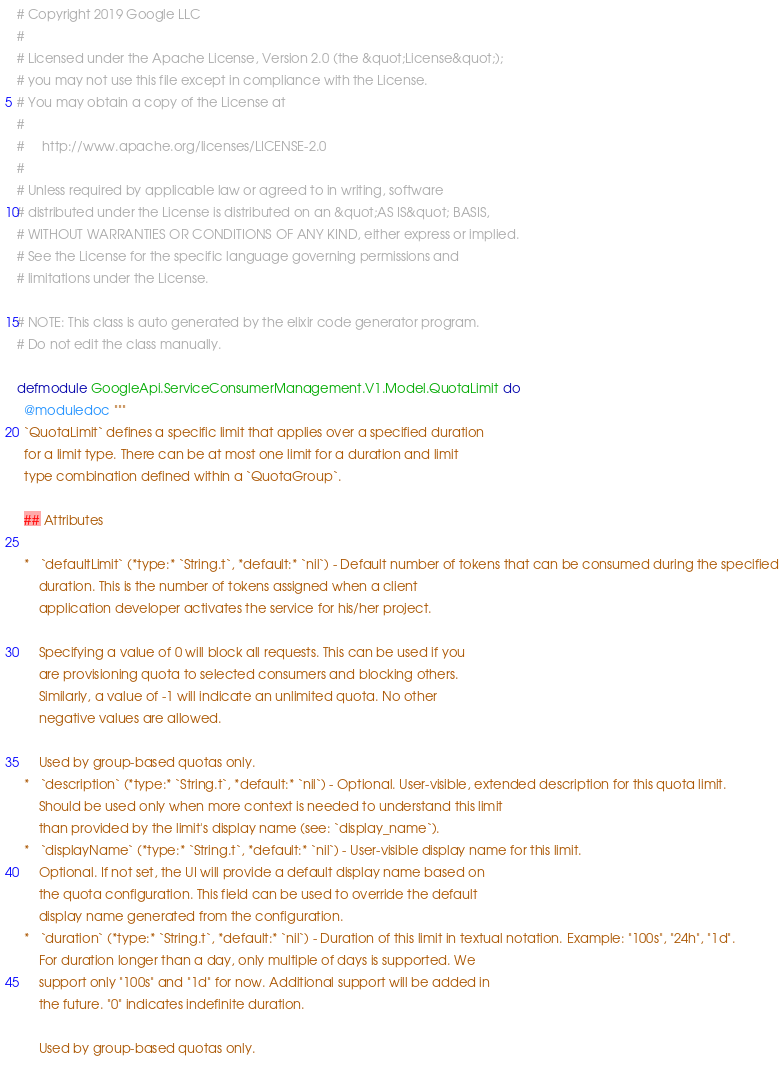Convert code to text. <code><loc_0><loc_0><loc_500><loc_500><_Elixir_># Copyright 2019 Google LLC
#
# Licensed under the Apache License, Version 2.0 (the &quot;License&quot;);
# you may not use this file except in compliance with the License.
# You may obtain a copy of the License at
#
#     http://www.apache.org/licenses/LICENSE-2.0
#
# Unless required by applicable law or agreed to in writing, software
# distributed under the License is distributed on an &quot;AS IS&quot; BASIS,
# WITHOUT WARRANTIES OR CONDITIONS OF ANY KIND, either express or implied.
# See the License for the specific language governing permissions and
# limitations under the License.

# NOTE: This class is auto generated by the elixir code generator program.
# Do not edit the class manually.

defmodule GoogleApi.ServiceConsumerManagement.V1.Model.QuotaLimit do
  @moduledoc """
  `QuotaLimit` defines a specific limit that applies over a specified duration
  for a limit type. There can be at most one limit for a duration and limit
  type combination defined within a `QuotaGroup`.

  ## Attributes

  *   `defaultLimit` (*type:* `String.t`, *default:* `nil`) - Default number of tokens that can be consumed during the specified
      duration. This is the number of tokens assigned when a client
      application developer activates the service for his/her project.

      Specifying a value of 0 will block all requests. This can be used if you
      are provisioning quota to selected consumers and blocking others.
      Similarly, a value of -1 will indicate an unlimited quota. No other
      negative values are allowed.

      Used by group-based quotas only.
  *   `description` (*type:* `String.t`, *default:* `nil`) - Optional. User-visible, extended description for this quota limit.
      Should be used only when more context is needed to understand this limit
      than provided by the limit's display name (see: `display_name`).
  *   `displayName` (*type:* `String.t`, *default:* `nil`) - User-visible display name for this limit.
      Optional. If not set, the UI will provide a default display name based on
      the quota configuration. This field can be used to override the default
      display name generated from the configuration.
  *   `duration` (*type:* `String.t`, *default:* `nil`) - Duration of this limit in textual notation. Example: "100s", "24h", "1d".
      For duration longer than a day, only multiple of days is supported. We
      support only "100s" and "1d" for now. Additional support will be added in
      the future. "0" indicates indefinite duration.

      Used by group-based quotas only.</code> 